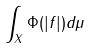Convert formula to latex. <formula><loc_0><loc_0><loc_500><loc_500>\int _ { X } \Phi ( | f | ) d \mu</formula> 